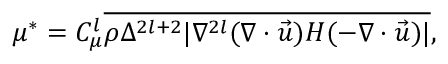Convert formula to latex. <formula><loc_0><loc_0><loc_500><loc_500>\mu ^ { * } = { C } _ { \mu } ^ { l } \overline { { \rho \Delta ^ { 2 l + 2 } | \nabla ^ { 2 l } ( \nabla \cdot \vec { u } ) H ( - \nabla \cdot \vec { u } ) | } } ,</formula> 